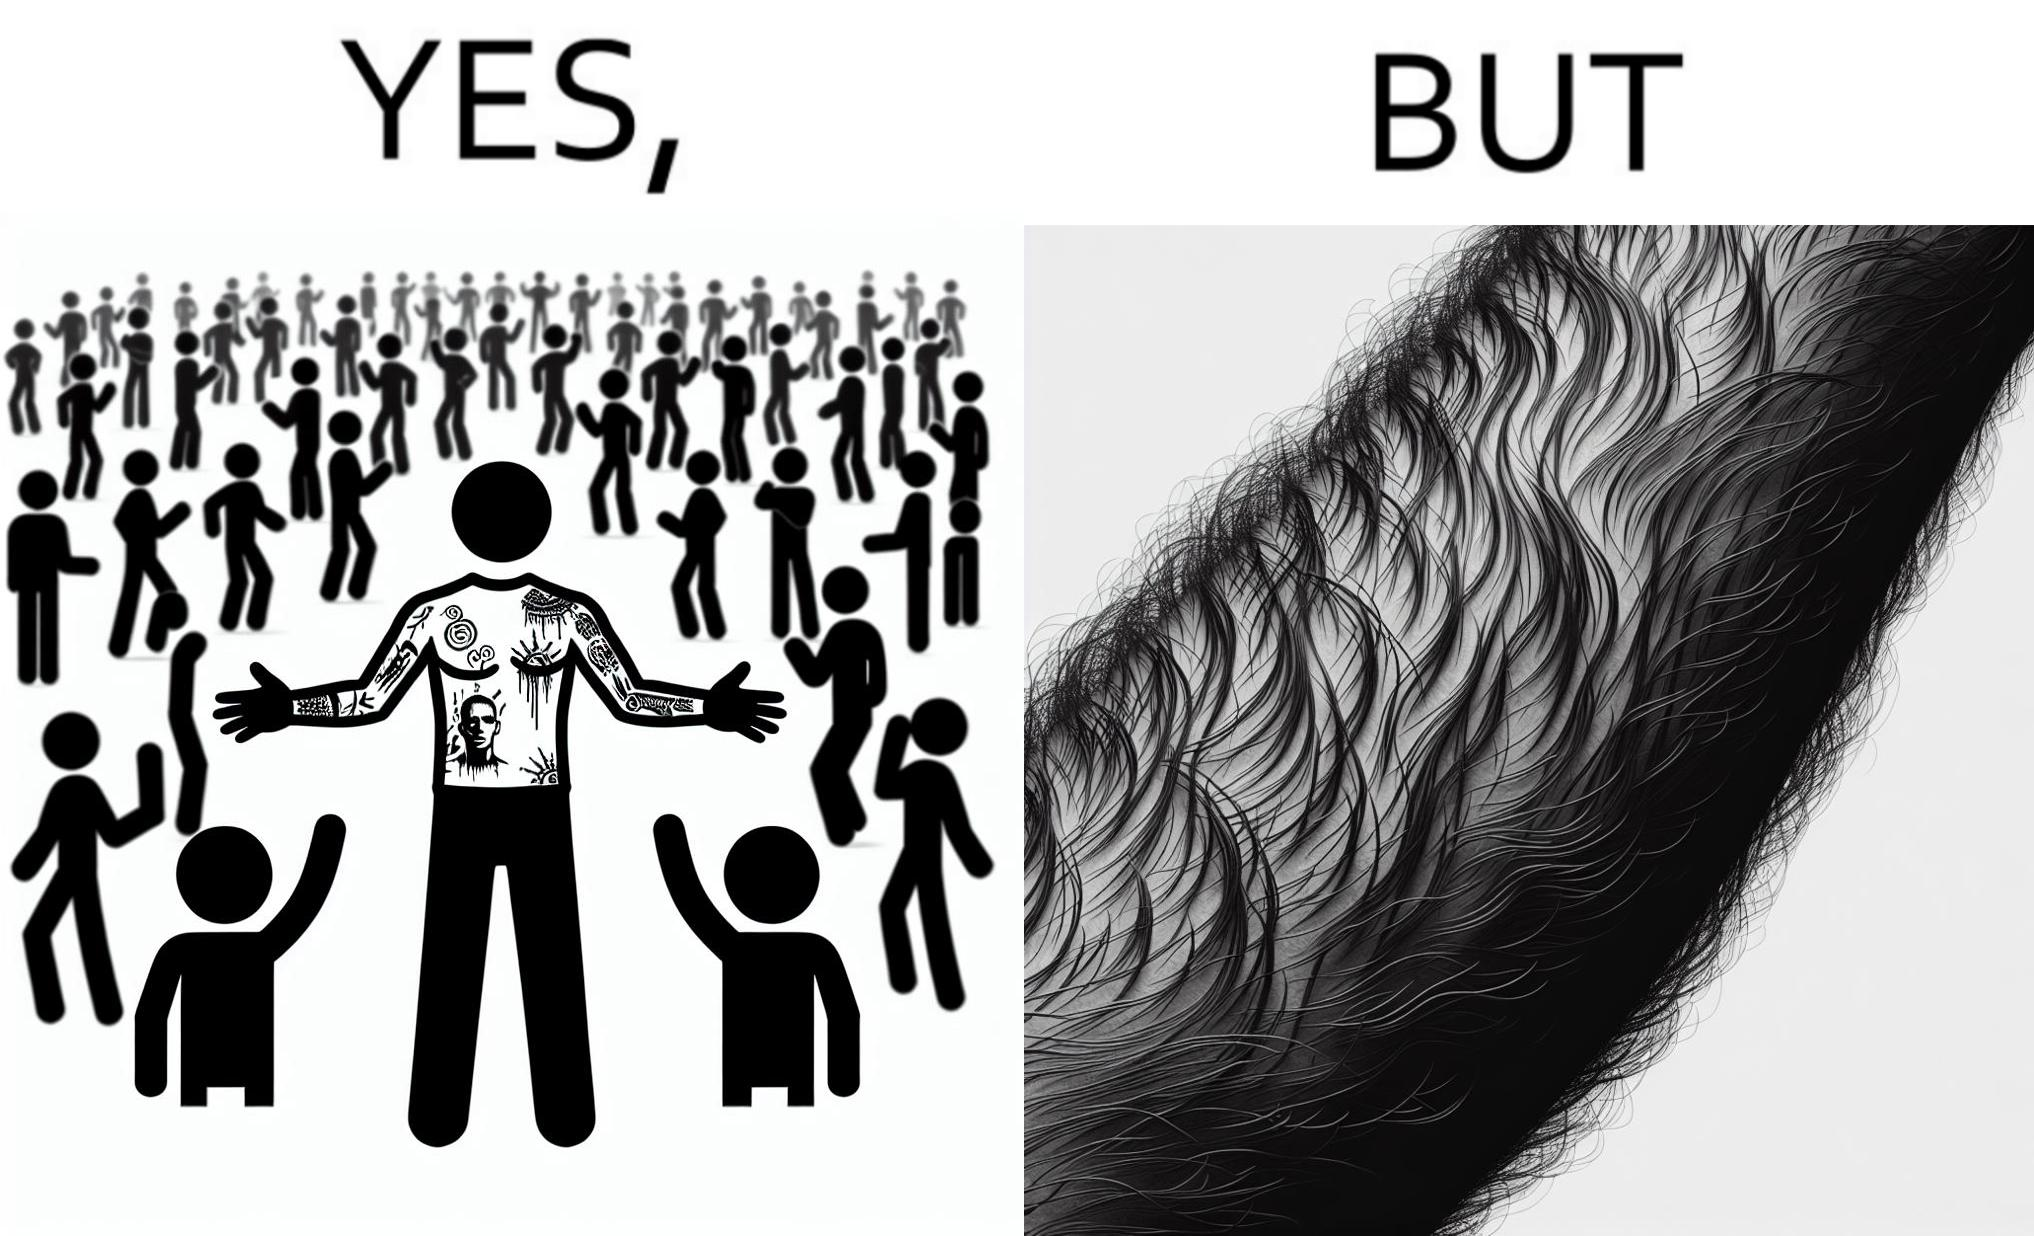Describe what you see in the left and right parts of this image. In the left part of the image: The image shows a man with tattoos on both of his arms. He is wearing white T-shirt . In the right part of the image: The image shows a closeup of an arm. The arm is shown to be very hairy and the hairs are wavy. 